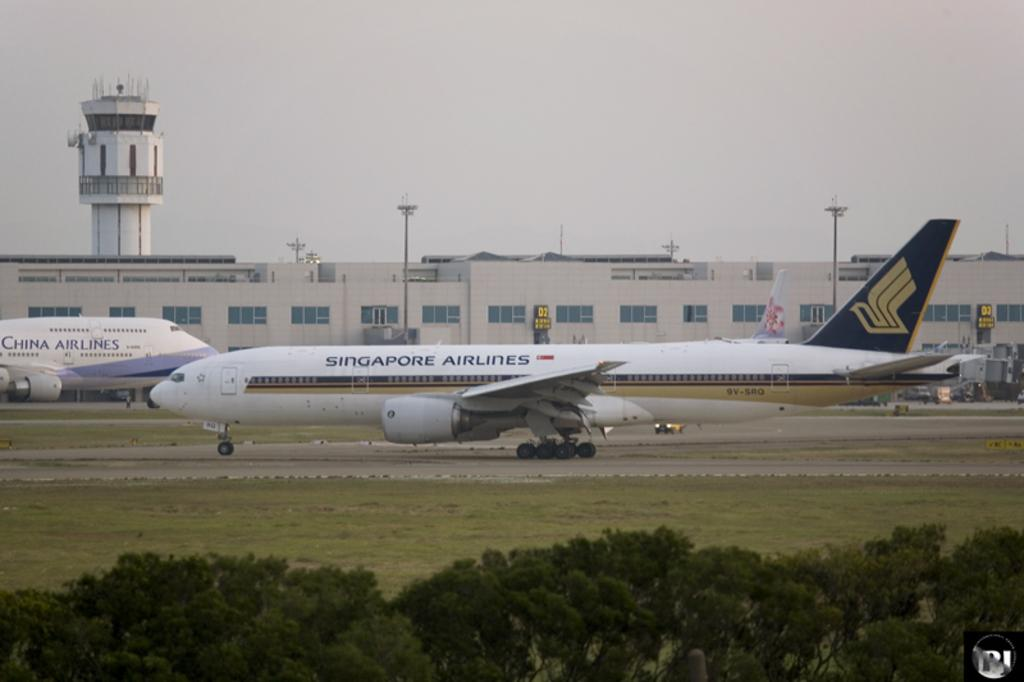<image>
Summarize the visual content of the image. A white Singapore Airlines plane is taxiing on the runway. 